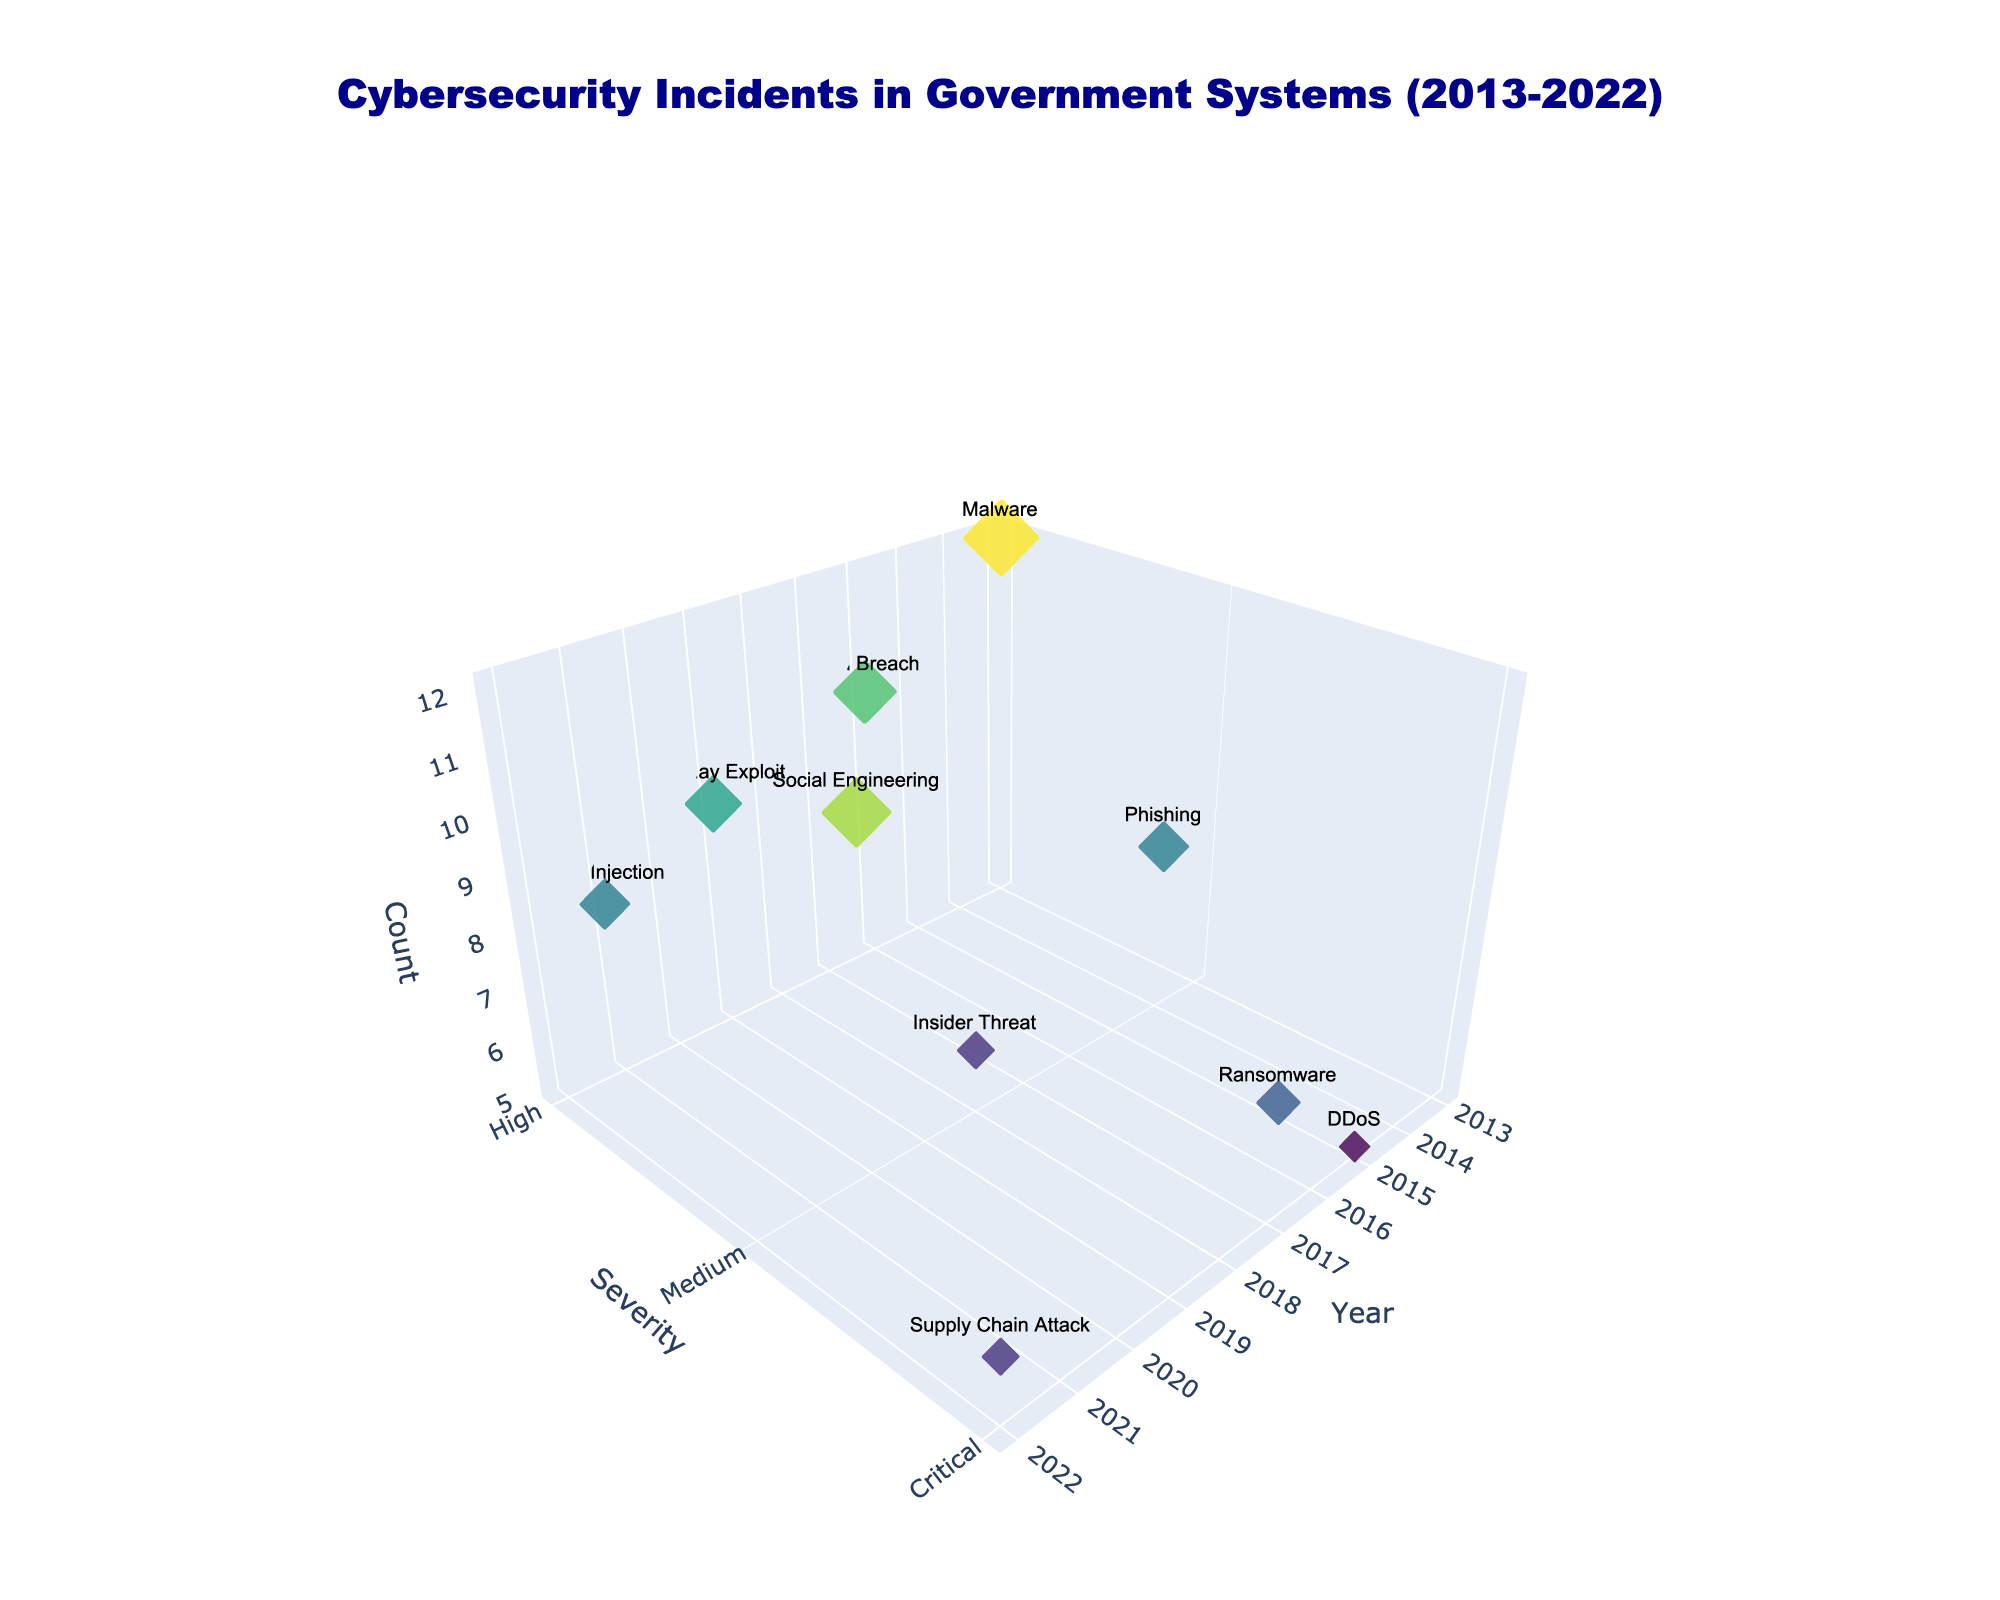What are the years shown on the x-axis? The x-axis represents the timeline from 2013 to 2022 as indicated by the ticks on the axis.
Answer: 2013 to 2022 Which agency has the highest count of incidents in the figure? By examining the marker size (which represents incident counts) and the hovertext, the Department of Justice in 2020 has the largest marker.
Answer: Department of Justice What's the severity and incident type with the highest count in 2017? Looking at the plot for 2017, the largest marker corresponds to a Critical severity and is labeled with Ransomware.
Answer: Critical, Ransomware How many total incidents are represented in the figure? There are 10 markers, each representing a year from 2013 to 2022, signifying 10 total incidents shown.
Answer: 10 What is the most common severity level among the incidents? By counting the markers associated with each severity level (High, Medium, Critical), 'High' appears most frequently in the plot.
Answer: High What are the incident types and counts for the year 2015? By referencing the x-axis for 2015, the hovertext shows 5 DDoS incidents.
Answer: DDoS, 5 Which incident type had a medium severity level and affected the Federal Bureau of Investigation? The hovertext for markers at the Medium severity level in different years shows that 'Insider Threat' had a medium severity and affected the FBI in 2018.
Answer: Insider Threat Compare the severities of incidents in 2018 and 2021. Which one is higher? From the plot, the 2018 incident (Insider Threat) has a Medium severity, while the 2021 incident (SQL Injection) has a High severity. Higher severity would be the incident in 2021.
Answer: 2021 How does the count of incidents in 2014 compare to that of 2020? By reviewing marker sizes and hovertext, 2014 has a count of 8 (Phishing) and 2020 has a count of 11 (Social Engineering). The count in 2020 is higher.
Answer: 2020 What Agency had a Critical severity level incident due to a Supply Chain Attack, and what was the count? By referencing the 2022 marker in the plot, the hovertext shows that it was the Cybersecurity and Infrastructure Security Agency with a count of 6.
Answer: Cybersecurity and Infrastructure Security Agency, 6 